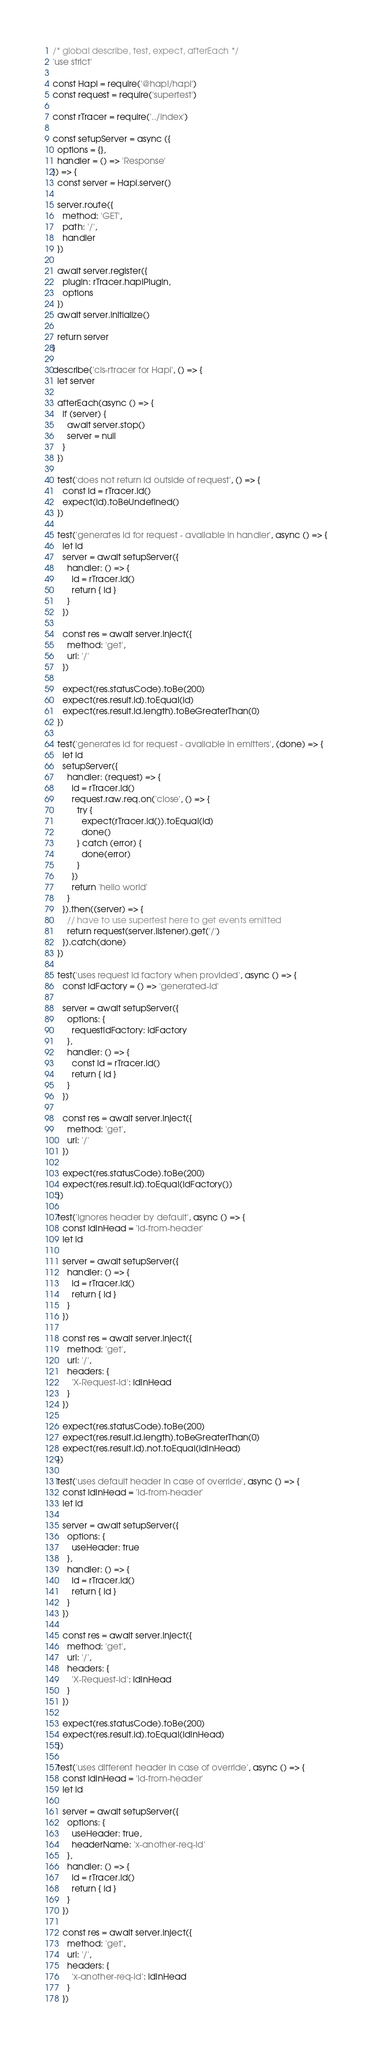Convert code to text. <code><loc_0><loc_0><loc_500><loc_500><_JavaScript_>/* global describe, test, expect, afterEach */
'use strict'

const Hapi = require('@hapi/hapi')
const request = require('supertest')

const rTracer = require('../index')

const setupServer = async ({
  options = {},
  handler = () => 'Response'
}) => {
  const server = Hapi.server()

  server.route({
    method: 'GET',
    path: '/',
    handler
  })

  await server.register({
    plugin: rTracer.hapiPlugin,
    options
  })
  await server.initialize()

  return server
}

describe('cls-rtracer for Hapi', () => {
  let server

  afterEach(async () => {
    if (server) {
      await server.stop()
      server = null
    }
  })

  test('does not return id outside of request', () => {
    const id = rTracer.id()
    expect(id).toBeUndefined()
  })

  test('generates id for request - available in handler', async () => {
    let id
    server = await setupServer({
      handler: () => {
        id = rTracer.id()
        return { id }
      }
    })

    const res = await server.inject({
      method: 'get',
      url: '/'
    })

    expect(res.statusCode).toBe(200)
    expect(res.result.id).toEqual(id)
    expect(res.result.id.length).toBeGreaterThan(0)
  })

  test('generates id for request - available in emitters', (done) => {
    let id
    setupServer({
      handler: (request) => {
        id = rTracer.id()
        request.raw.req.on('close', () => {
          try {
            expect(rTracer.id()).toEqual(id)
            done()
          } catch (error) {
            done(error)
          }
        })
        return 'hello world'
      }
    }).then((server) => {
      // have to use supertest here to get events emitted
      return request(server.listener).get('/')
    }).catch(done)
  })

  test('uses request id factory when provided', async () => {
    const idFactory = () => 'generated-id'

    server = await setupServer({
      options: {
        requestIdFactory: idFactory
      },
      handler: () => {
        const id = rTracer.id()
        return { id }
      }
    })

    const res = await server.inject({
      method: 'get',
      url: '/'
    })

    expect(res.statusCode).toBe(200)
    expect(res.result.id).toEqual(idFactory())
  })

  test('ignores header by default', async () => {
    const idInHead = 'id-from-header'
    let id

    server = await setupServer({
      handler: () => {
        id = rTracer.id()
        return { id }
      }
    })

    const res = await server.inject({
      method: 'get',
      url: '/',
      headers: {
        'X-Request-Id': idInHead
      }
    })

    expect(res.statusCode).toBe(200)
    expect(res.result.id.length).toBeGreaterThan(0)
    expect(res.result.id).not.toEqual(idInHead)
  })

  test('uses default header in case of override', async () => {
    const idInHead = 'id-from-header'
    let id

    server = await setupServer({
      options: {
        useHeader: true
      },
      handler: () => {
        id = rTracer.id()
        return { id }
      }
    })

    const res = await server.inject({
      method: 'get',
      url: '/',
      headers: {
        'X-Request-Id': idInHead
      }
    })

    expect(res.statusCode).toBe(200)
    expect(res.result.id).toEqual(idInHead)
  })

  test('uses different header in case of override', async () => {
    const idInHead = 'id-from-header'
    let id

    server = await setupServer({
      options: {
        useHeader: true,
        headerName: 'x-another-req-id'
      },
      handler: () => {
        id = rTracer.id()
        return { id }
      }
    })

    const res = await server.inject({
      method: 'get',
      url: '/',
      headers: {
        'x-another-req-id': idInHead
      }
    })
</code> 